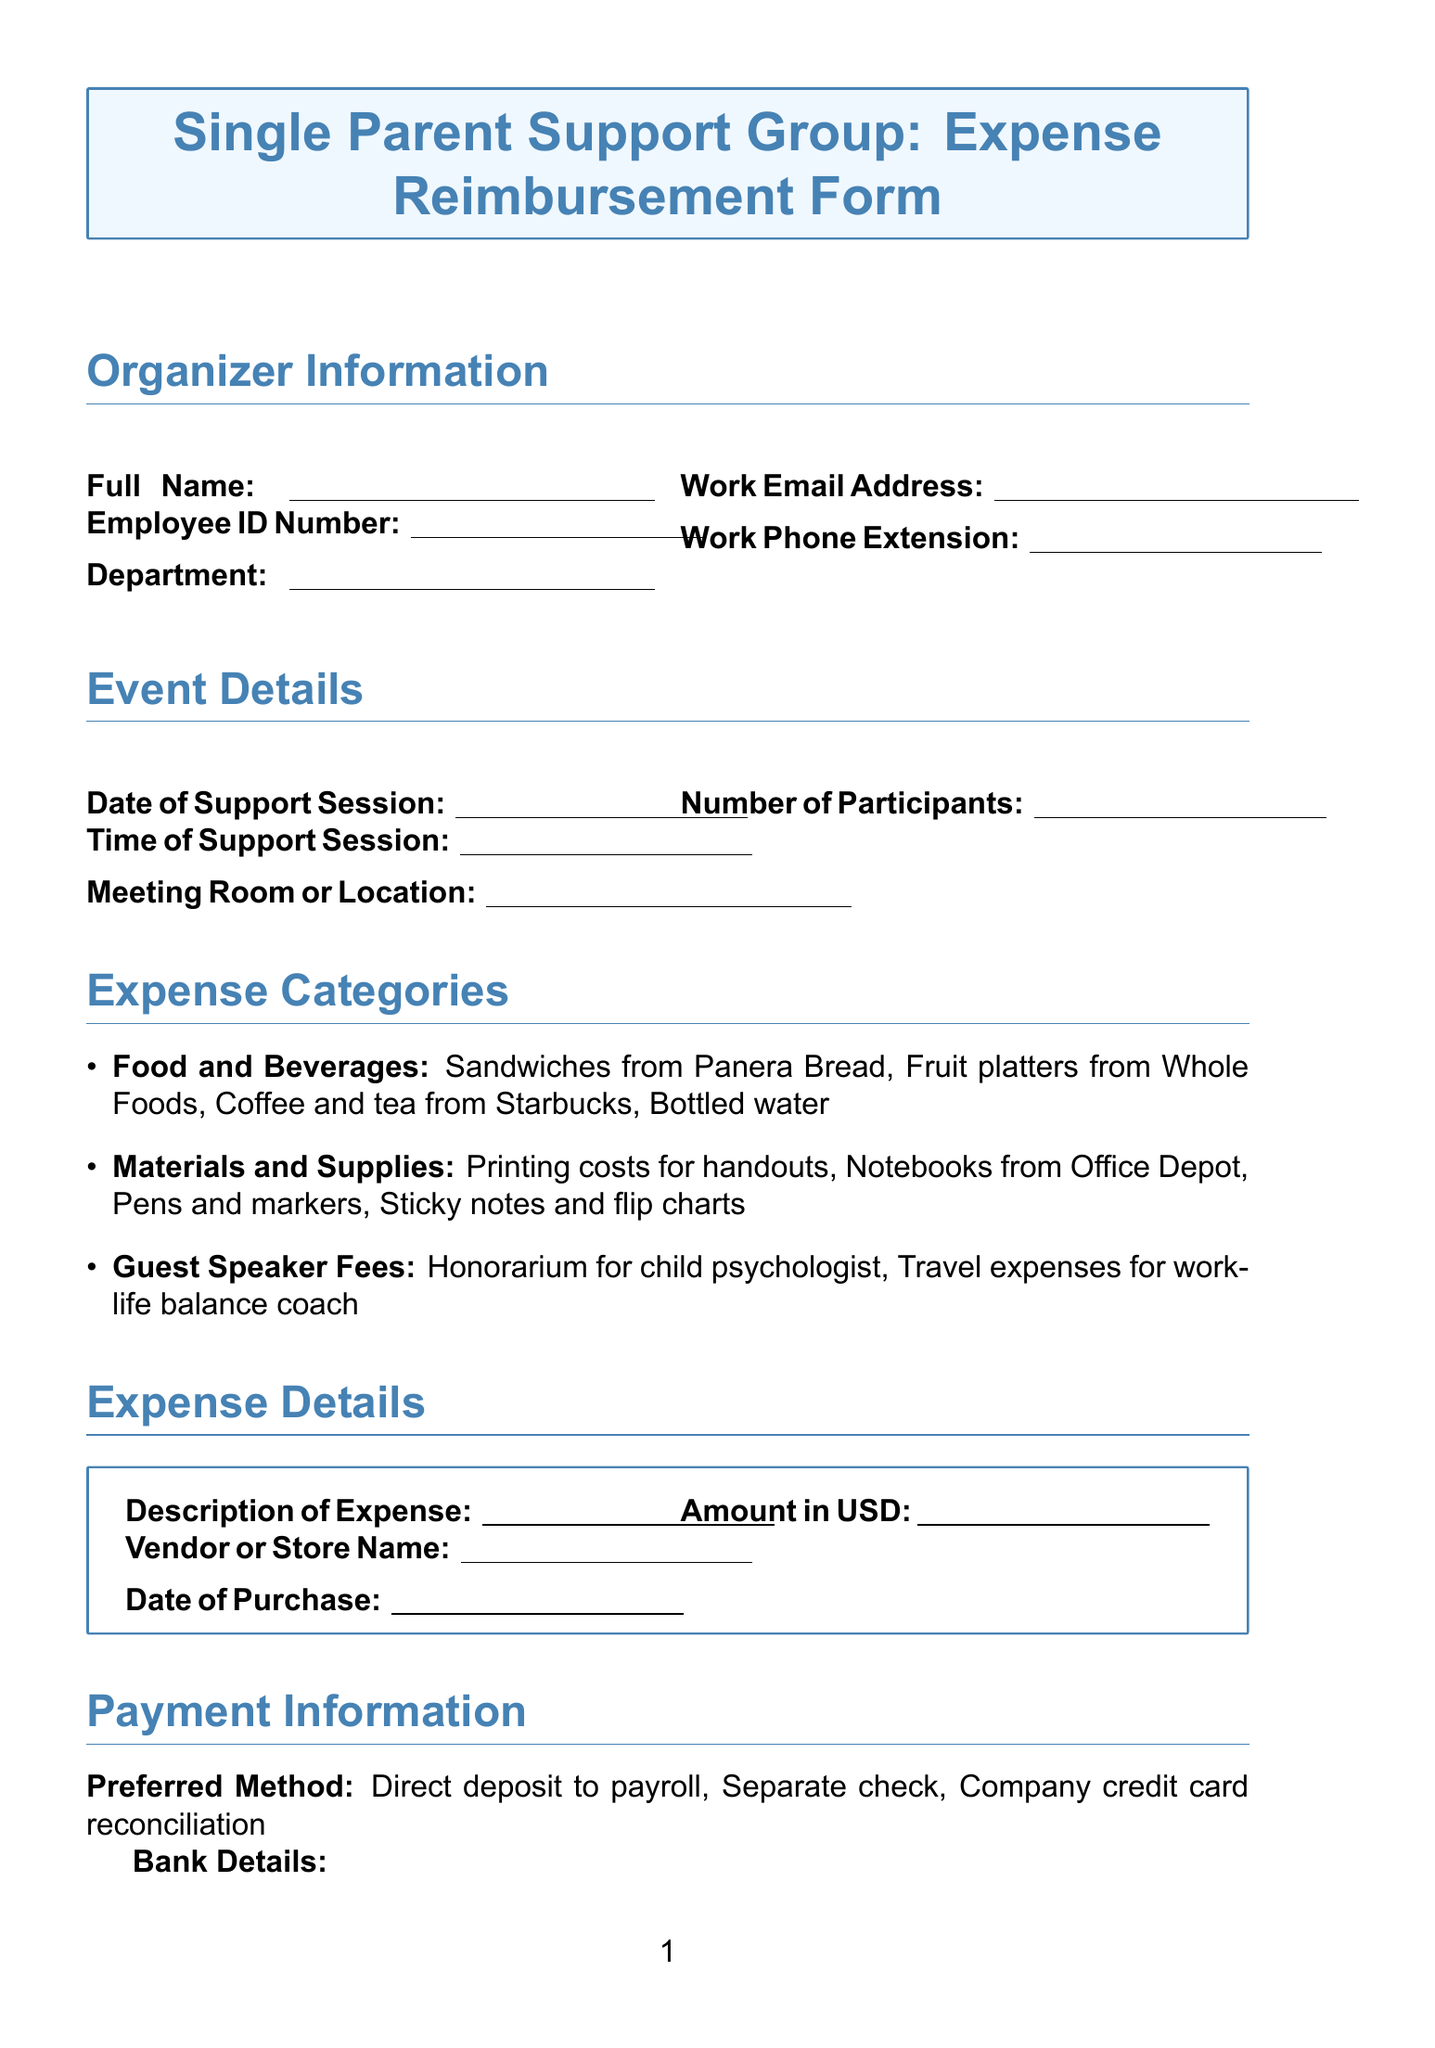What is the title of the form? The title of the form is stated at the top of the document.
Answer: Single Parent Support Group: Expense Reimbursement Form What is the maximum reimbursement per session? The maximum reimbursement is explicitly mentioned in the additional information section.
Answer: $150 Who should the reimbursement requests be submitted to? This information can be inferred from the document's structure and additional information provided.
Answer: HR Benefits team What is required for expenses over $25? This requirement is detailed under the additional information section of the document.
Answer: Original receipts What is the deadline for submitting reimbursement requests? The deadline is clearly stated in the additional information section.
Answer: 30 days What types of expenses can be reimbursed? The document provides a list of expense categories that are eligible for reimbursement.
Answer: Food and Beverages, Materials and Supplies, Guest Speaker Fees How should the payment be received according to the preferred method? The preferred methods for payment are outlined in the payment information section.
Answer: Direct deposit to payroll, Separate check, Company credit card reconciliation What is one example of materials and supplies? The document lists examples in the expense categories section which can be directly referenced.
Answer: Notebooks from Office Depot What information is needed from the immediate supervisor? The approval section details the information required from the immediate supervisor.
Answer: Supervisor's Name, Signature, Date of Approval 